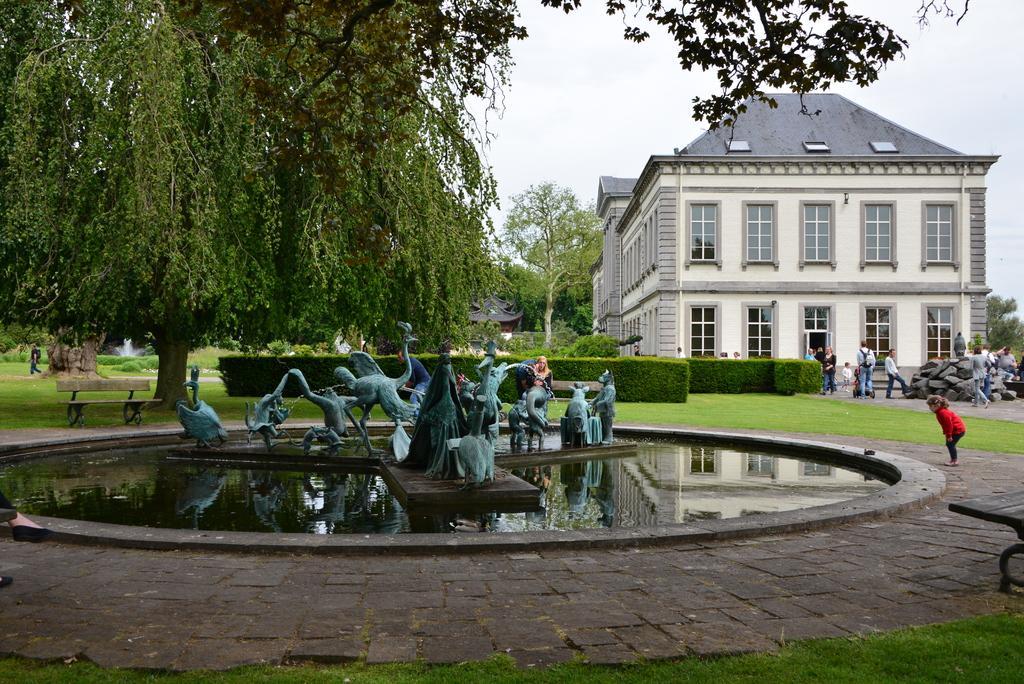Can you describe this image briefly? In this image in the front there's grass on the ground. In the center there are statues and there is water pond. In the background there are trees, there is a building and there are persons and on the left side there is an empty bench and there are plants. In the background on the right side there are stones. 